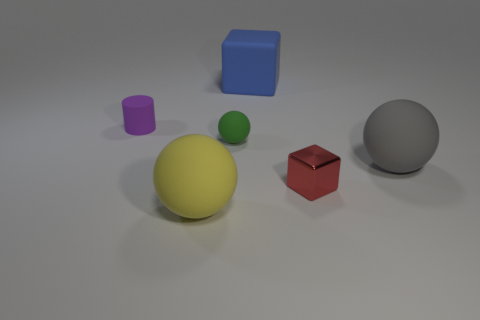The gray ball that is made of the same material as the cylinder is what size?
Your response must be concise. Large. What size is the green rubber object that is the same shape as the gray object?
Your answer should be very brief. Small. Are there any blue shiny balls?
Make the answer very short. No. What number of things are either tiny objects that are to the right of the large yellow object or small purple rubber cylinders?
Offer a very short reply. 3. What material is the block that is the same size as the purple cylinder?
Your response must be concise. Metal. There is a big object behind the large thing that is to the right of the tiny red shiny thing; what color is it?
Make the answer very short. Blue. How many big cubes are in front of the gray rubber ball?
Offer a terse response. 0. The metallic thing is what color?
Offer a terse response. Red. How many small things are either matte things or purple metallic cylinders?
Provide a succinct answer. 2. There is a tiny thing that is on the left side of the yellow matte sphere; what shape is it?
Make the answer very short. Cylinder. 